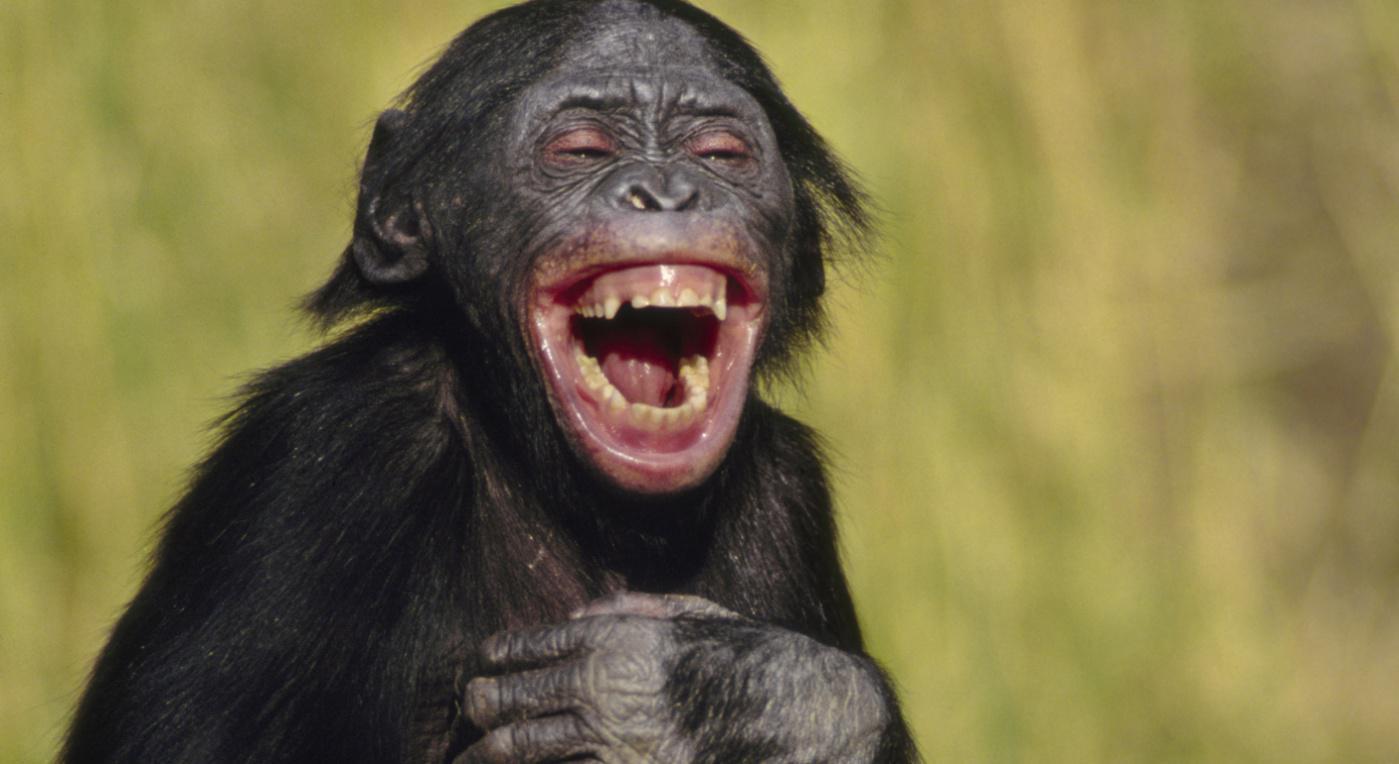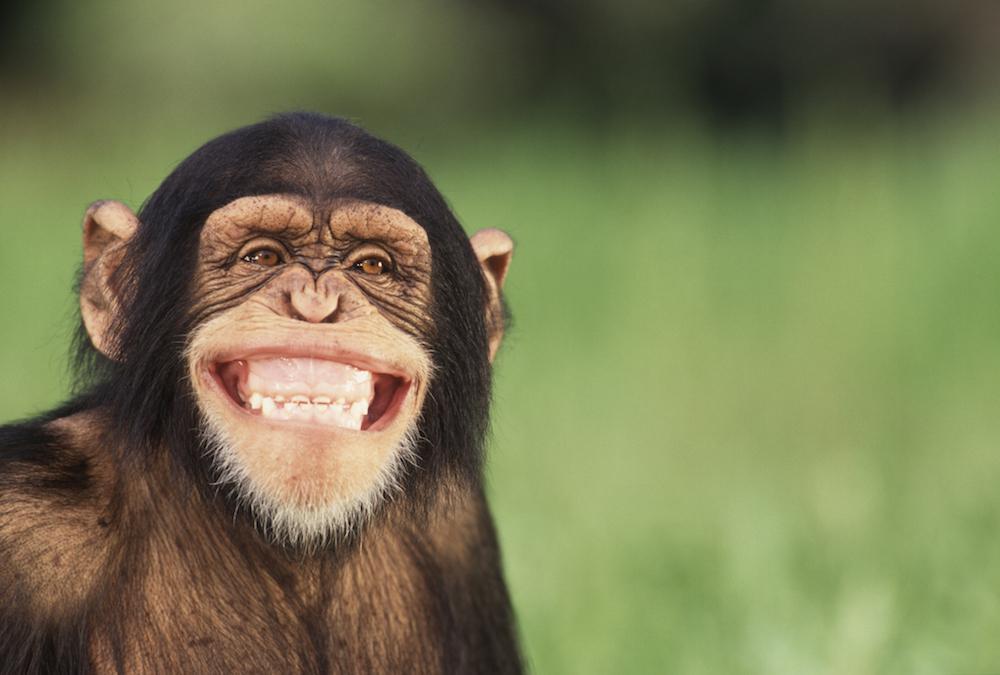The first image is the image on the left, the second image is the image on the right. Considering the images on both sides, is "One image in each pair has at least one chimpanzee hugging another one." valid? Answer yes or no. No. The first image is the image on the left, the second image is the image on the right. For the images displayed, is the sentence "There are at most two chimpanzees." factually correct? Answer yes or no. Yes. 